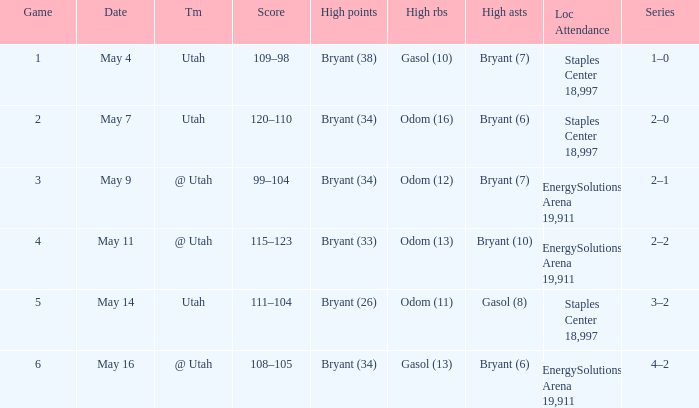What is the High rebounds with a High assists with bryant (7), and a Team of @ utah? Odom (12). 